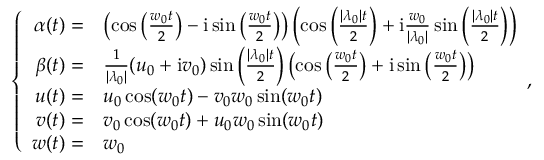Convert formula to latex. <formula><loc_0><loc_0><loc_500><loc_500>\left \{ \begin{array} { r l } { \alpha ( t ) = } & { \left ( \cos \left ( \frac { w _ { 0 } t } { 2 } \right ) - i \sin \left ( \frac { w _ { 0 } t } { 2 } \right ) \right ) \left ( \cos \left ( \frac { | \lambda _ { 0 } | t } { 2 } \right ) + i \frac { w _ { 0 } } { | \lambda _ { 0 } | } \sin \left ( \frac { | \lambda _ { 0 } | t } { 2 } \right ) \right ) } \\ { \beta ( t ) = } & { \frac { 1 } { | \lambda _ { 0 } | } ( u _ { 0 } + i v _ { 0 } ) \sin \left ( \frac { | \lambda _ { 0 } | t } { 2 } \right ) \left ( \cos \left ( \frac { w _ { 0 } t } { 2 } \right ) + i \sin \left ( \frac { w _ { 0 } t } { 2 } \right ) \right ) } \\ { u ( t ) = } & { u _ { 0 } \cos ( w _ { 0 } t ) - v _ { 0 } w _ { 0 } \sin ( w _ { 0 } t ) } \\ { v ( t ) = } & { v _ { 0 } \cos ( w _ { 0 } t ) + u _ { 0 } w _ { 0 } \sin ( w _ { 0 } t ) } \\ { w ( t ) = } & { w _ { 0 } } \end{array} ,</formula> 